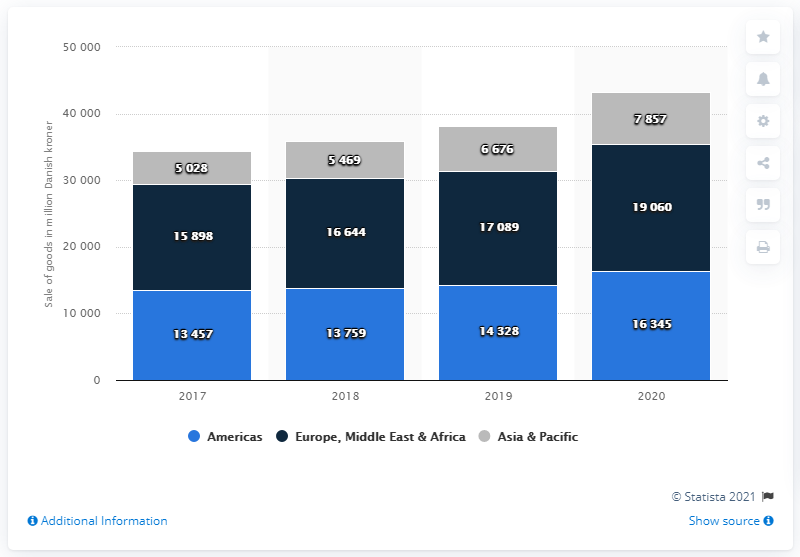Indicate a few pertinent items in this graphic. In 2020, the LEGO Group achieved the highest net sales in the Americas. The Lego Group's net sales in the Americas region in 2020 were approximately 16,345. In the Americas from 2017 to 2020, the net sales showed a difference of 2888. In the year of 2020, the Lego Group achieved net sales of 16.35 billion Danish kroner in the Americas region. 